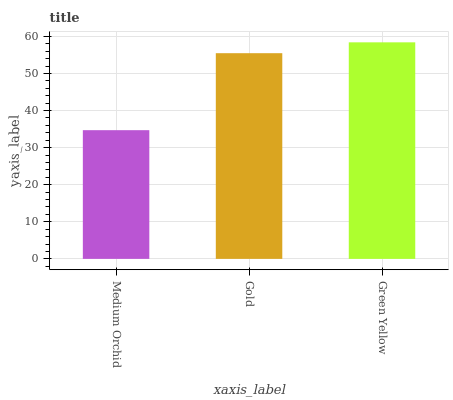Is Medium Orchid the minimum?
Answer yes or no. Yes. Is Green Yellow the maximum?
Answer yes or no. Yes. Is Gold the minimum?
Answer yes or no. No. Is Gold the maximum?
Answer yes or no. No. Is Gold greater than Medium Orchid?
Answer yes or no. Yes. Is Medium Orchid less than Gold?
Answer yes or no. Yes. Is Medium Orchid greater than Gold?
Answer yes or no. No. Is Gold less than Medium Orchid?
Answer yes or no. No. Is Gold the high median?
Answer yes or no. Yes. Is Gold the low median?
Answer yes or no. Yes. Is Medium Orchid the high median?
Answer yes or no. No. Is Medium Orchid the low median?
Answer yes or no. No. 